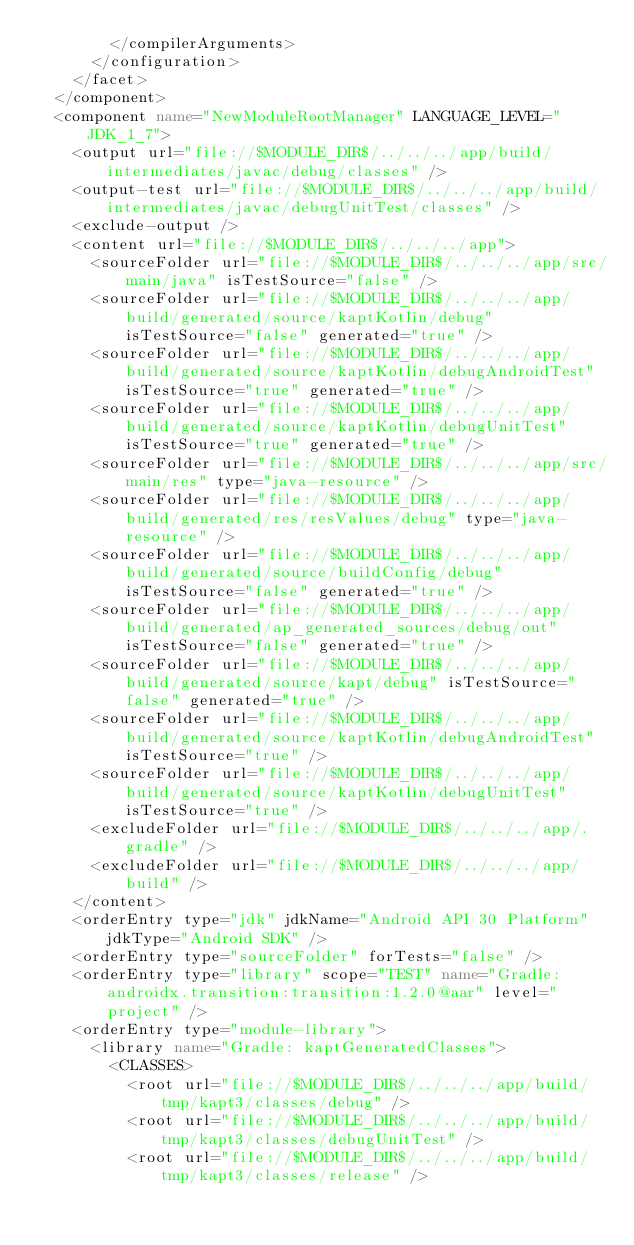Convert code to text. <code><loc_0><loc_0><loc_500><loc_500><_XML_>        </compilerArguments>
      </configuration>
    </facet>
  </component>
  <component name="NewModuleRootManager" LANGUAGE_LEVEL="JDK_1_7">
    <output url="file://$MODULE_DIR$/../../../app/build/intermediates/javac/debug/classes" />
    <output-test url="file://$MODULE_DIR$/../../../app/build/intermediates/javac/debugUnitTest/classes" />
    <exclude-output />
    <content url="file://$MODULE_DIR$/../../../app">
      <sourceFolder url="file://$MODULE_DIR$/../../../app/src/main/java" isTestSource="false" />
      <sourceFolder url="file://$MODULE_DIR$/../../../app/build/generated/source/kaptKotlin/debug" isTestSource="false" generated="true" />
      <sourceFolder url="file://$MODULE_DIR$/../../../app/build/generated/source/kaptKotlin/debugAndroidTest" isTestSource="true" generated="true" />
      <sourceFolder url="file://$MODULE_DIR$/../../../app/build/generated/source/kaptKotlin/debugUnitTest" isTestSource="true" generated="true" />
      <sourceFolder url="file://$MODULE_DIR$/../../../app/src/main/res" type="java-resource" />
      <sourceFolder url="file://$MODULE_DIR$/../../../app/build/generated/res/resValues/debug" type="java-resource" />
      <sourceFolder url="file://$MODULE_DIR$/../../../app/build/generated/source/buildConfig/debug" isTestSource="false" generated="true" />
      <sourceFolder url="file://$MODULE_DIR$/../../../app/build/generated/ap_generated_sources/debug/out" isTestSource="false" generated="true" />
      <sourceFolder url="file://$MODULE_DIR$/../../../app/build/generated/source/kapt/debug" isTestSource="false" generated="true" />
      <sourceFolder url="file://$MODULE_DIR$/../../../app/build/generated/source/kaptKotlin/debugAndroidTest" isTestSource="true" />
      <sourceFolder url="file://$MODULE_DIR$/../../../app/build/generated/source/kaptKotlin/debugUnitTest" isTestSource="true" />
      <excludeFolder url="file://$MODULE_DIR$/../../../app/.gradle" />
      <excludeFolder url="file://$MODULE_DIR$/../../../app/build" />
    </content>
    <orderEntry type="jdk" jdkName="Android API 30 Platform" jdkType="Android SDK" />
    <orderEntry type="sourceFolder" forTests="false" />
    <orderEntry type="library" scope="TEST" name="Gradle: androidx.transition:transition:1.2.0@aar" level="project" />
    <orderEntry type="module-library">
      <library name="Gradle: kaptGeneratedClasses">
        <CLASSES>
          <root url="file://$MODULE_DIR$/../../../app/build/tmp/kapt3/classes/debug" />
          <root url="file://$MODULE_DIR$/../../../app/build/tmp/kapt3/classes/debugUnitTest" />
          <root url="file://$MODULE_DIR$/../../../app/build/tmp/kapt3/classes/release" /></code> 